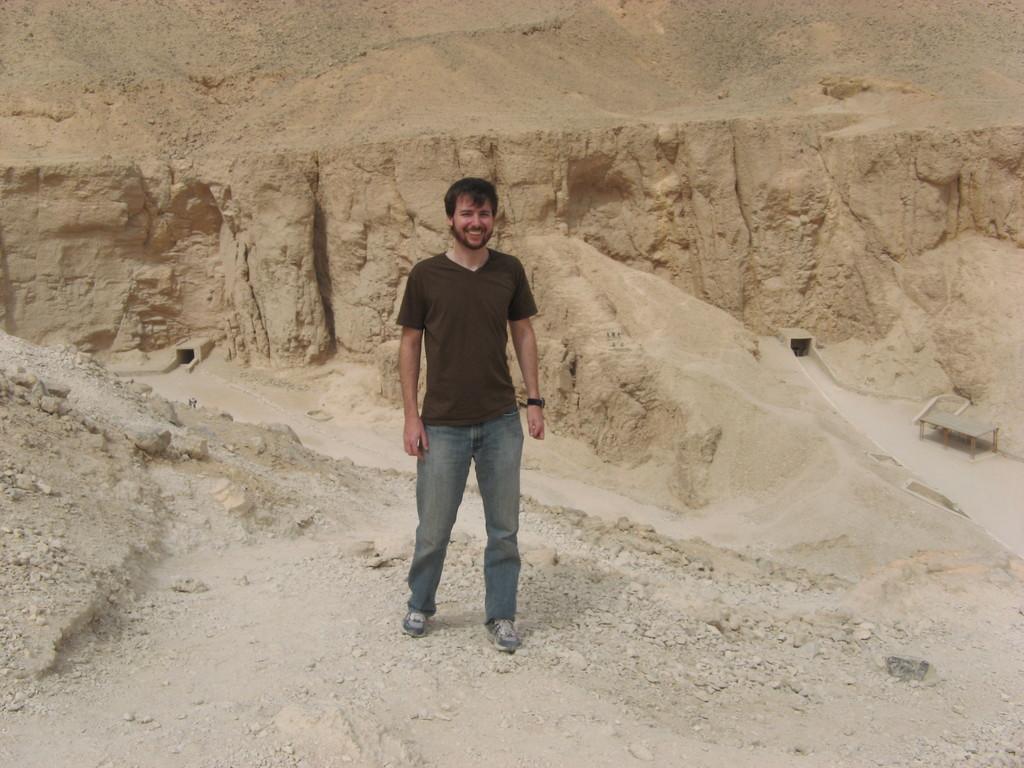Describe this image in one or two sentences. In the middle I can see a person is standing on the ground. In the background I can see a mountain. This image is taken may be during a day. 